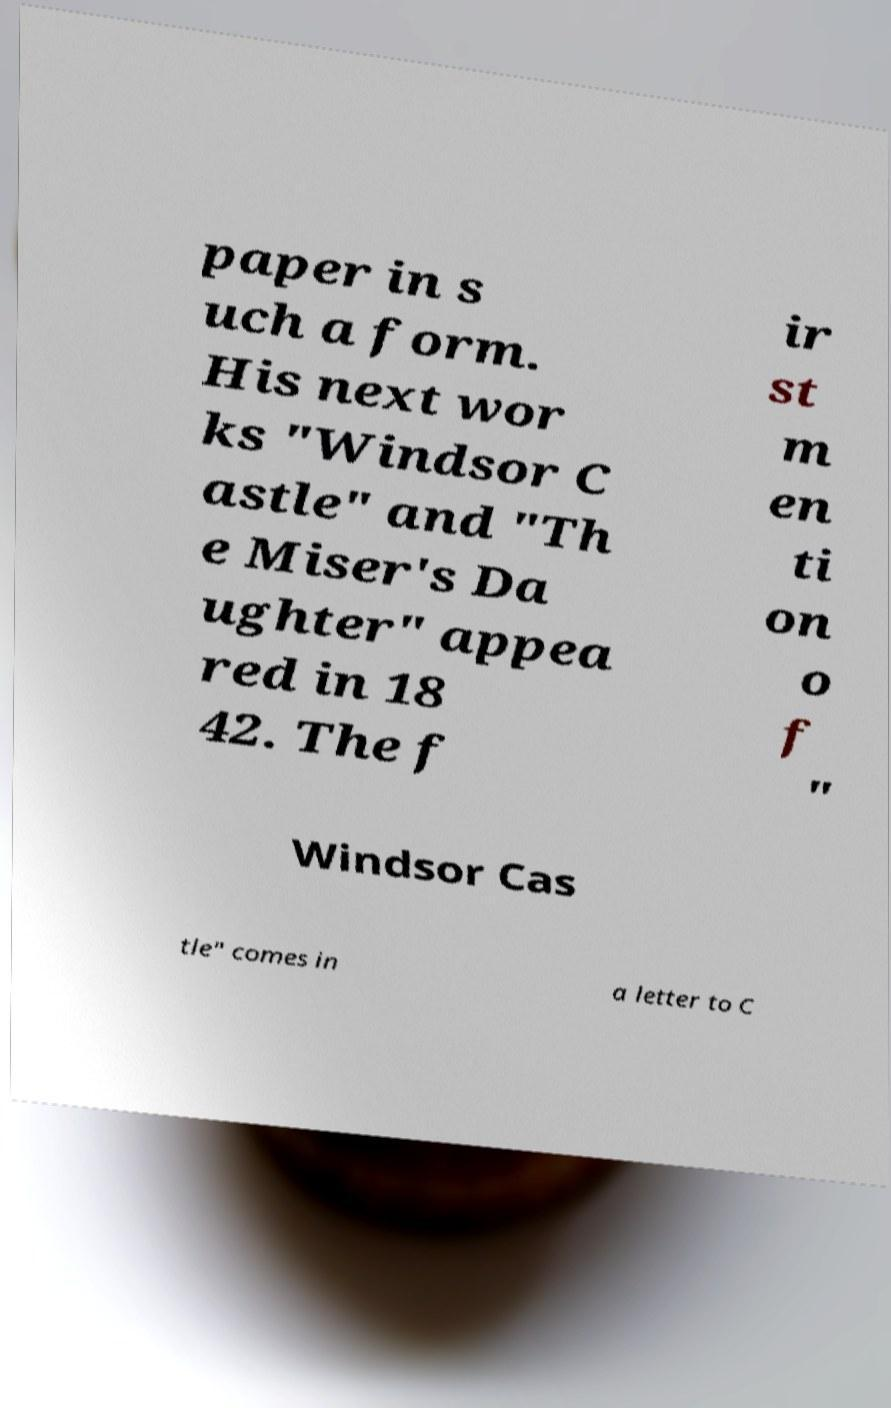I need the written content from this picture converted into text. Can you do that? paper in s uch a form. His next wor ks "Windsor C astle" and "Th e Miser's Da ughter" appea red in 18 42. The f ir st m en ti on o f " Windsor Cas tle" comes in a letter to C 